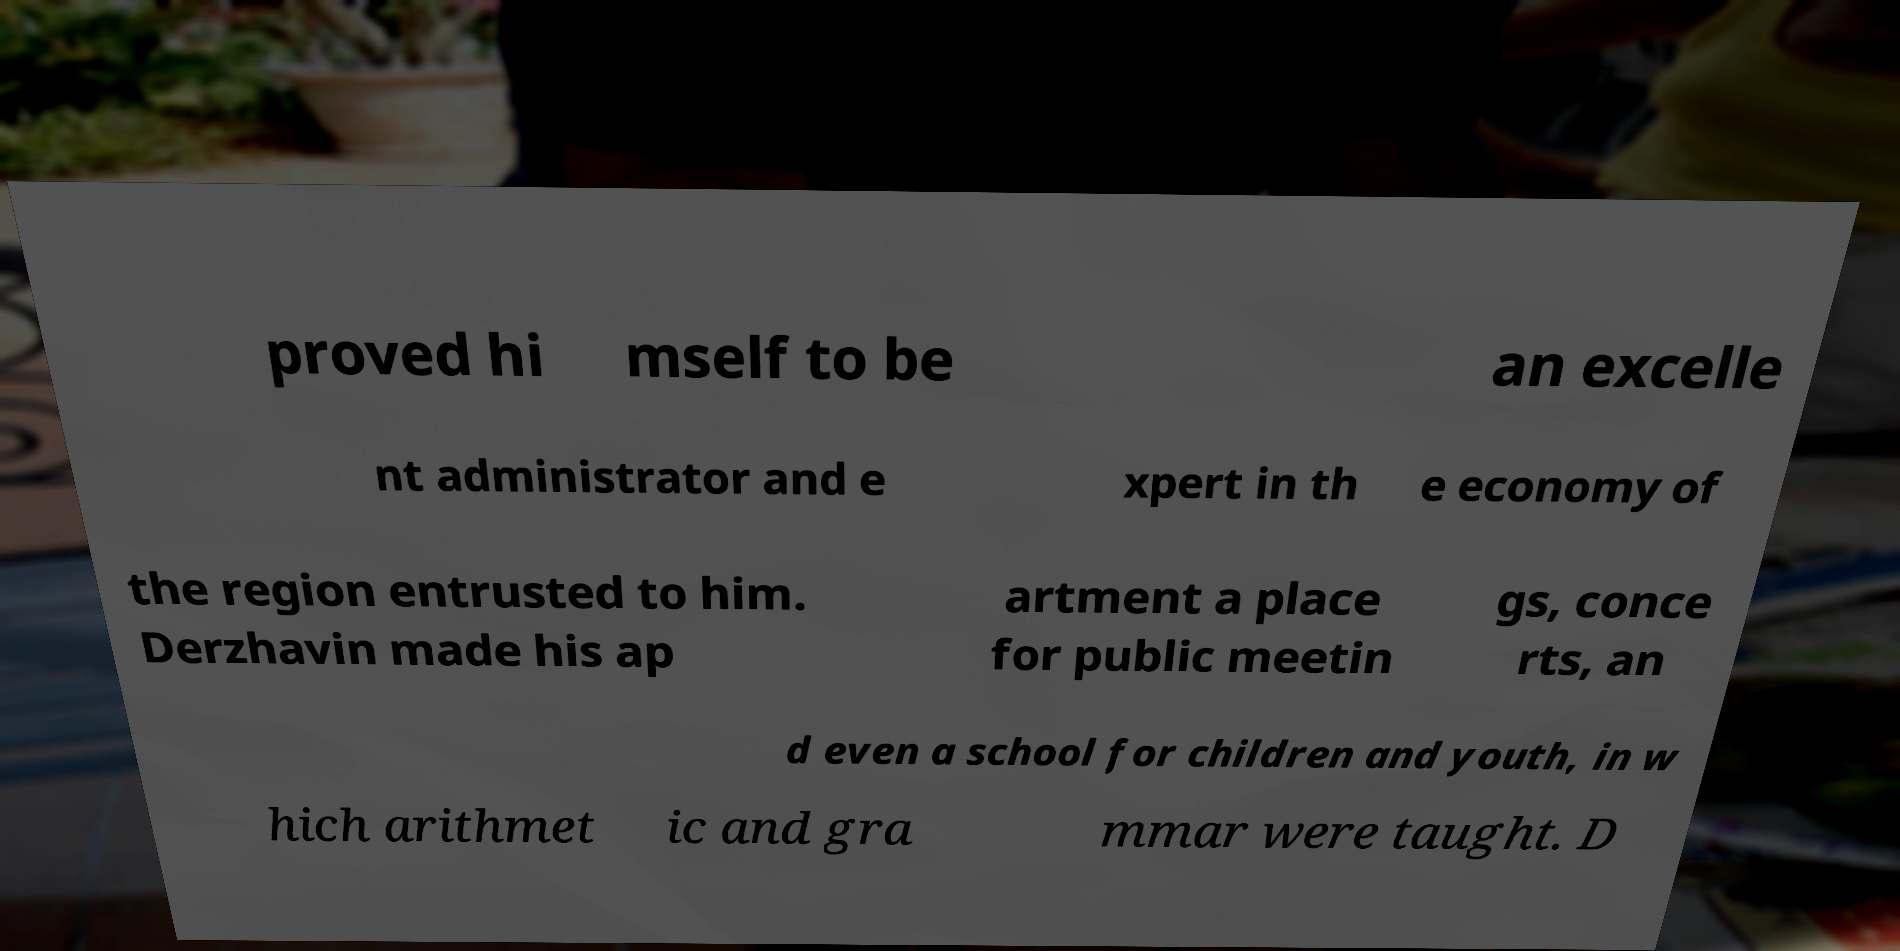Could you extract and type out the text from this image? proved hi mself to be an excelle nt administrator and e xpert in th e economy of the region entrusted to him. Derzhavin made his ap artment a place for public meetin gs, conce rts, an d even a school for children and youth, in w hich arithmet ic and gra mmar were taught. D 